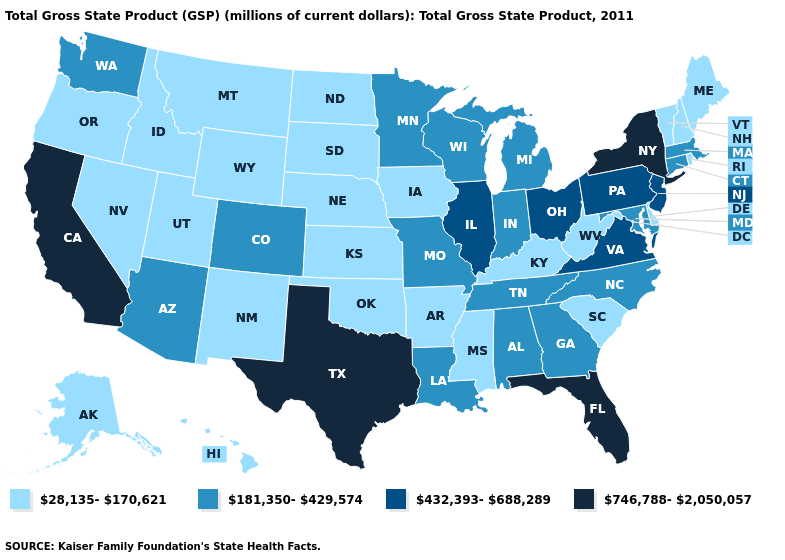Does the map have missing data?
Give a very brief answer. No. What is the value of Florida?
Short answer required. 746,788-2,050,057. Which states have the lowest value in the Northeast?
Give a very brief answer. Maine, New Hampshire, Rhode Island, Vermont. Does Illinois have the highest value in the MidWest?
Keep it brief. Yes. What is the value of Oregon?
Write a very short answer. 28,135-170,621. Among the states that border Colorado , does Oklahoma have the highest value?
Keep it brief. No. What is the lowest value in states that border Louisiana?
Give a very brief answer. 28,135-170,621. Name the states that have a value in the range 432,393-688,289?
Concise answer only. Illinois, New Jersey, Ohio, Pennsylvania, Virginia. Name the states that have a value in the range 28,135-170,621?
Quick response, please. Alaska, Arkansas, Delaware, Hawaii, Idaho, Iowa, Kansas, Kentucky, Maine, Mississippi, Montana, Nebraska, Nevada, New Hampshire, New Mexico, North Dakota, Oklahoma, Oregon, Rhode Island, South Carolina, South Dakota, Utah, Vermont, West Virginia, Wyoming. How many symbols are there in the legend?
Give a very brief answer. 4. Does the map have missing data?
Answer briefly. No. Name the states that have a value in the range 28,135-170,621?
Quick response, please. Alaska, Arkansas, Delaware, Hawaii, Idaho, Iowa, Kansas, Kentucky, Maine, Mississippi, Montana, Nebraska, Nevada, New Hampshire, New Mexico, North Dakota, Oklahoma, Oregon, Rhode Island, South Carolina, South Dakota, Utah, Vermont, West Virginia, Wyoming. What is the value of Florida?
Keep it brief. 746,788-2,050,057. 